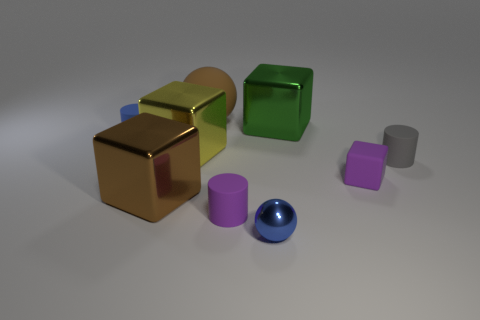Subtract 1 cubes. How many cubes are left? 3 Add 1 tiny brown metal blocks. How many objects exist? 10 Subtract all blocks. How many objects are left? 5 Add 2 yellow metallic things. How many yellow metallic things are left? 3 Add 5 blue cylinders. How many blue cylinders exist? 6 Subtract 0 cyan balls. How many objects are left? 9 Subtract all spheres. Subtract all large purple metal balls. How many objects are left? 7 